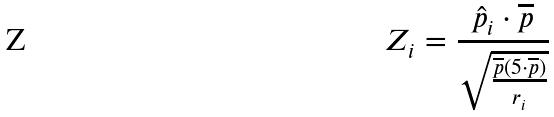Convert formula to latex. <formula><loc_0><loc_0><loc_500><loc_500>Z _ { i } = \frac { \hat { p } _ { i } \cdot \overline { p } } { \sqrt { \frac { \overline { p } ( 5 \cdot \overline { p } ) } { r _ { i } } } }</formula> 